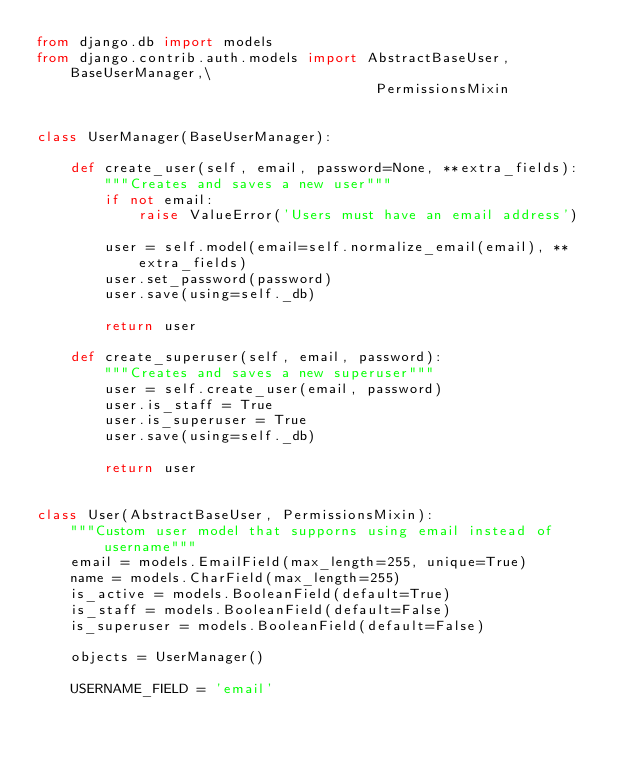Convert code to text. <code><loc_0><loc_0><loc_500><loc_500><_Python_>from django.db import models
from django.contrib.auth.models import AbstractBaseUser, BaseUserManager,\
                                        PermissionsMixin


class UserManager(BaseUserManager):

    def create_user(self, email, password=None, **extra_fields):
        """Creates and saves a new user"""
        if not email:
            raise ValueError('Users must have an email address')

        user = self.model(email=self.normalize_email(email), **extra_fields)
        user.set_password(password)
        user.save(using=self._db)

        return user

    def create_superuser(self, email, password):
        """Creates and saves a new superuser"""
        user = self.create_user(email, password)
        user.is_staff = True
        user.is_superuser = True
        user.save(using=self._db)

        return user


class User(AbstractBaseUser, PermissionsMixin):
    """Custom user model that supporns using email instead of username"""
    email = models.EmailField(max_length=255, unique=True)
    name = models.CharField(max_length=255)
    is_active = models.BooleanField(default=True)
    is_staff = models.BooleanField(default=False)
    is_superuser = models.BooleanField(default=False)

    objects = UserManager()

    USERNAME_FIELD = 'email'
</code> 